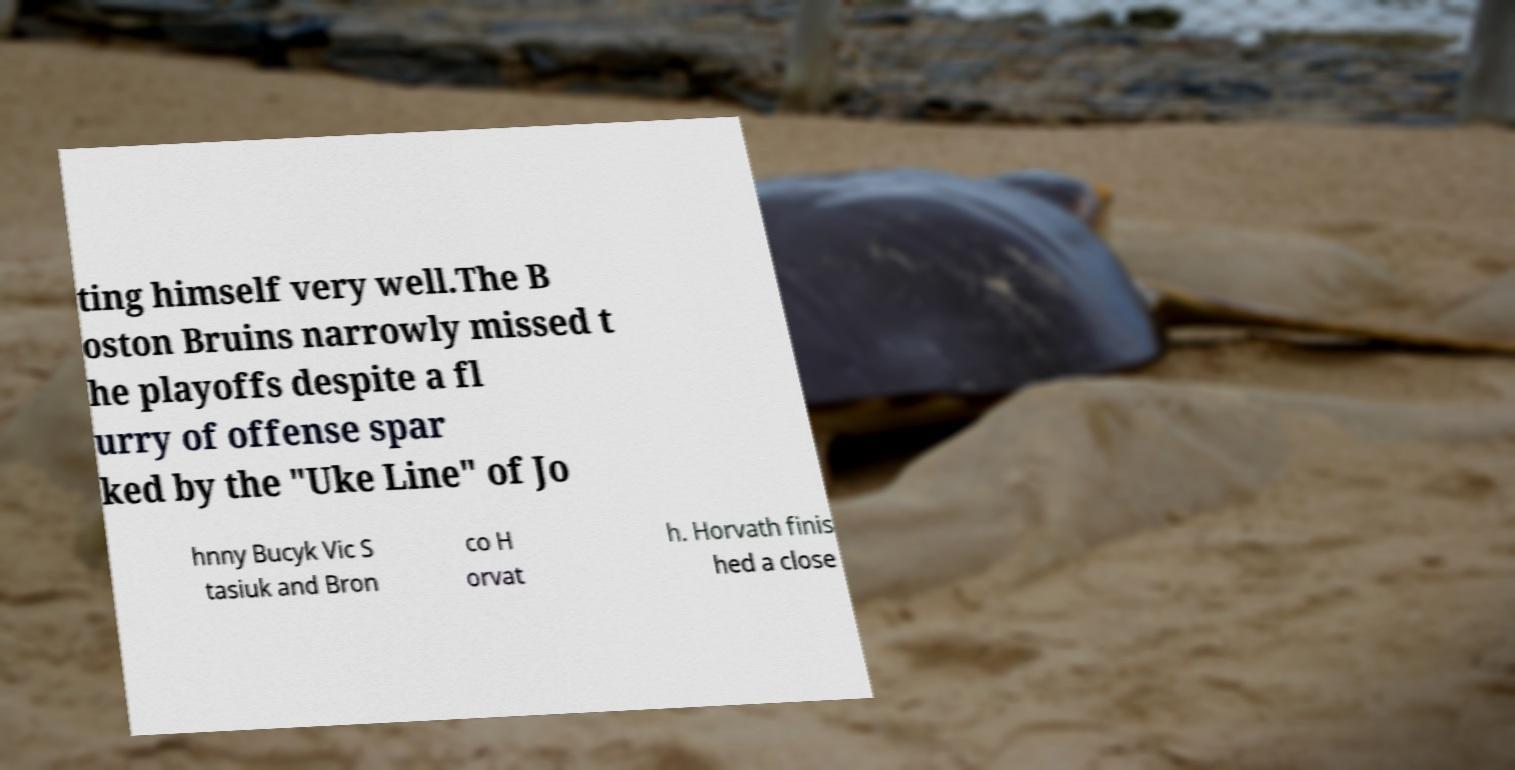Could you assist in decoding the text presented in this image and type it out clearly? ting himself very well.The B oston Bruins narrowly missed t he playoffs despite a fl urry of offense spar ked by the "Uke Line" of Jo hnny Bucyk Vic S tasiuk and Bron co H orvat h. Horvath finis hed a close 